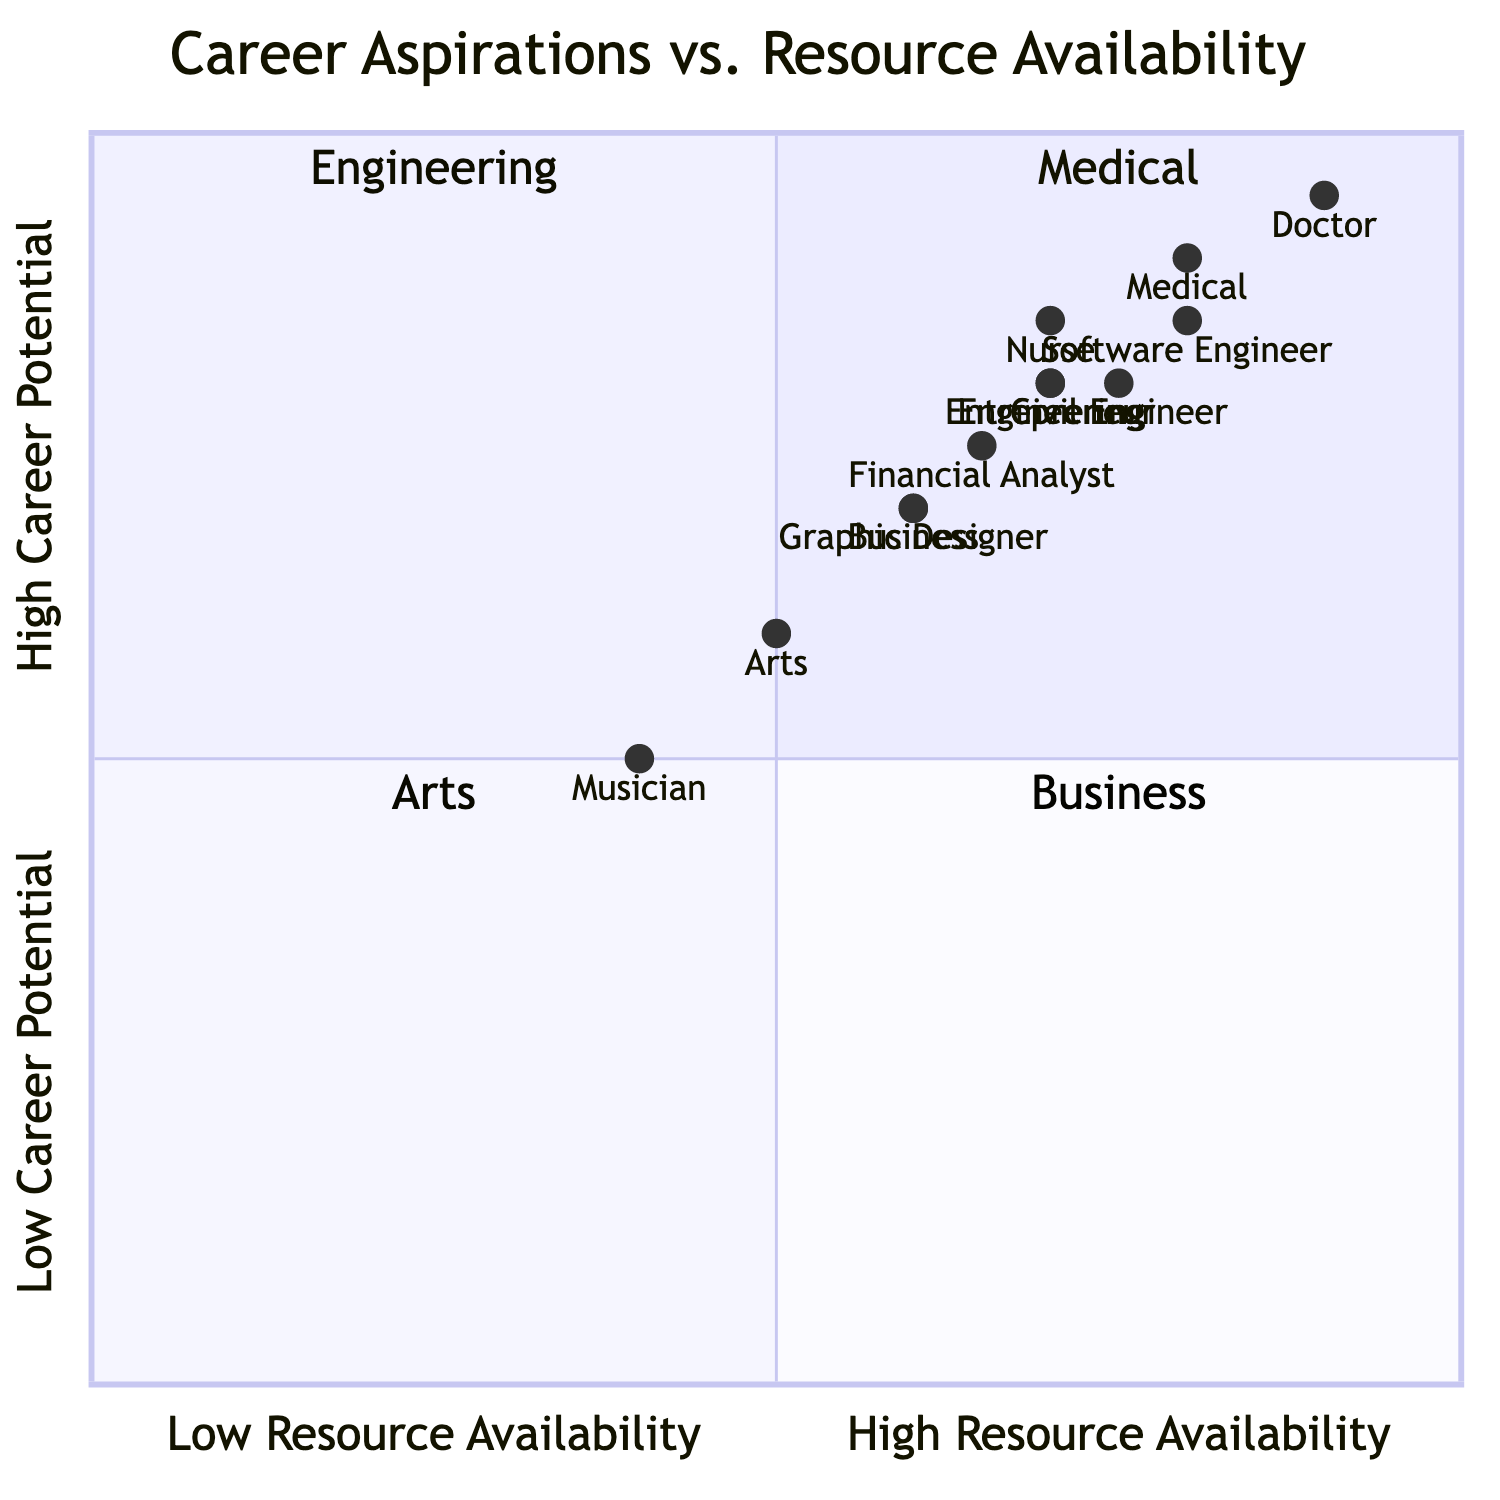What are the career goals listed under Medical? The diagram specifies the career goals in the Medical quadrant, which are Doctor, Nurse, and Medical Researcher. This information is directly accessible from the data provided for that quadrant.
Answer: Doctor, Nurse, Medical Researcher Which career goal has the highest resource availability in the Medical quadrant? The Doctor career goal in the Medical quadrant has the highest resource availability, indicated by its positioning in the quadrant and the resource values it represents.
Answer: Doctor How many scholarships are available for Engineering careers? There are two scholarships listed in the Engineering quadrant, which are the Society of Women Engineers Scholarship and the Barry Goldwater Scholarship. This total can be directly counted from the resources section of the Engineering quadrant.
Answer: 2 What is the primary career goal in the Arts quadrant with the lowest potential? The Musician career goal has the lowest career potential in the Arts quadrant, as it is positioned lower compared to the other goals listed, specifically indicating its comparatively lower resource and career potential values.
Answer: Musician Which quadrant has the highest career potential? The Medical quadrant has the highest career potential, with its career goals positioned at higher ratios compared to the other quadrants, especially with the Doctor goal at 0.9 potential.
Answer: Medical How many internships are available in the Business quadrant? The Business quadrant lists two internships: the JP Morgan Chase Summer Internship and the Deloitte Summer Scholar Program. This can be directly counted from the internships section of the Business quadrant.
Answer: 2 Which career in Engineering has a higher career potential: Civil Engineer or Mechanical Engineer? The Software Engineer career has a higher potential than both Civil Engineer and Mechanical Engineer, with Software Engineer at 0.8 and the others at 0.75 and 0.7 respectively. This requires evaluating the specific career potential values attributed to each.
Answer: Software Engineer How do resources in the Arts quadrant compare to those in the Engineering quadrant? The Arts quadrant has lower resource availability overall, as indicated by its metrics, with a combination of scholarships, mentoring, and internships ranking lower compared to the Engineering quadrant's available resources. This involves comparing values from both quadrants for an assessment.
Answer: Lower Which quadrant has the lowest overall resource availability? The Arts quadrant has the lowest overall resource availability as shown in the diagram, which identifies it with the lowest position on the x-axis compared to the others.
Answer: Arts 